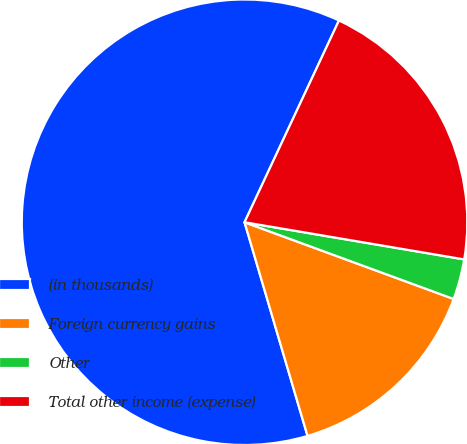Convert chart to OTSL. <chart><loc_0><loc_0><loc_500><loc_500><pie_chart><fcel>(in thousands)<fcel>Foreign currency gains<fcel>Other<fcel>Total other income (expense)<nl><fcel>61.53%<fcel>14.84%<fcel>2.93%<fcel>20.7%<nl></chart> 